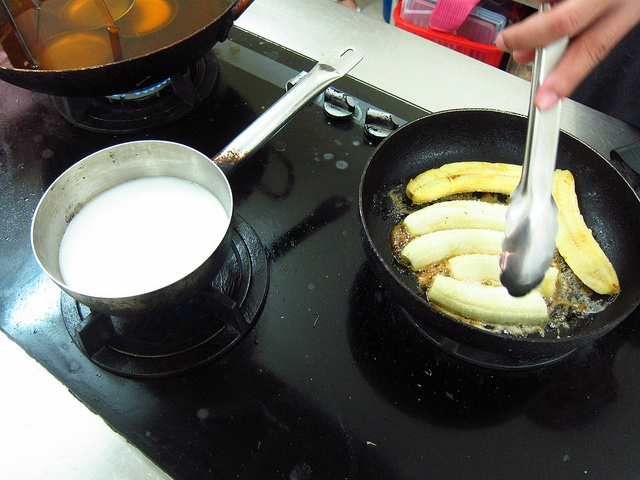Describe the objects in this image and their specific colors. I can see oven in black, ivory, gray, and khaki tones, spoon in black, ivory, darkgray, lightpink, and gray tones, people in black, brown, and salmon tones, banana in black, beige, khaki, and olive tones, and banana in black, khaki, lightyellow, and tan tones in this image. 